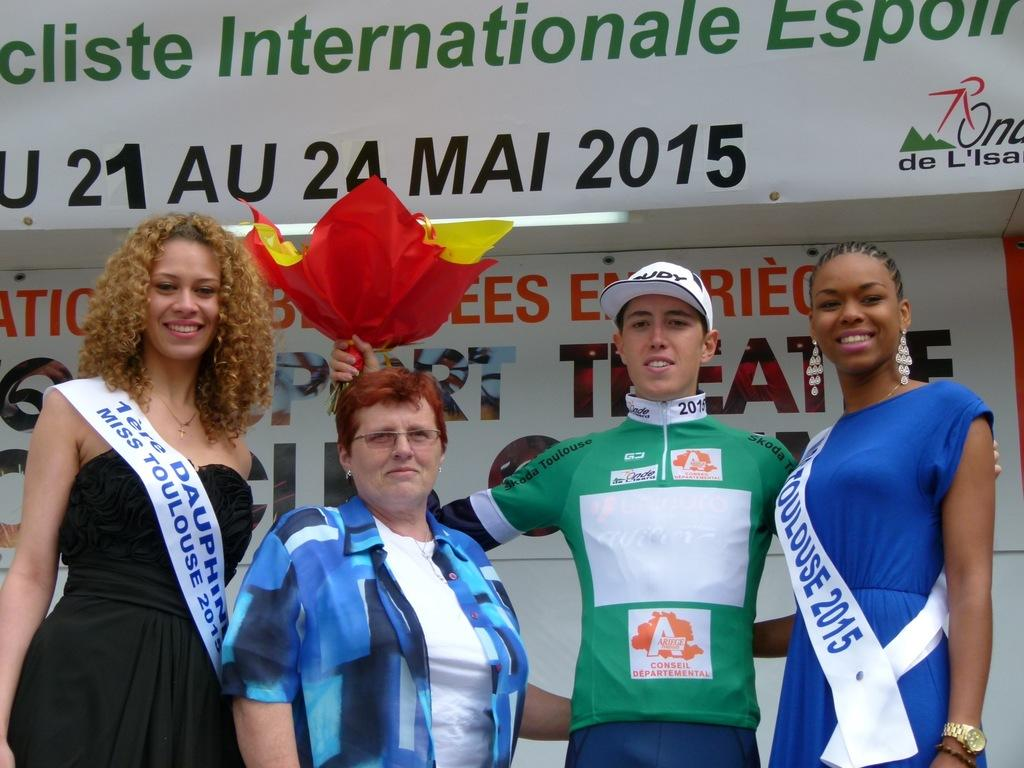<image>
Share a concise interpretation of the image provided. the 2015 international race with a pageant winners 